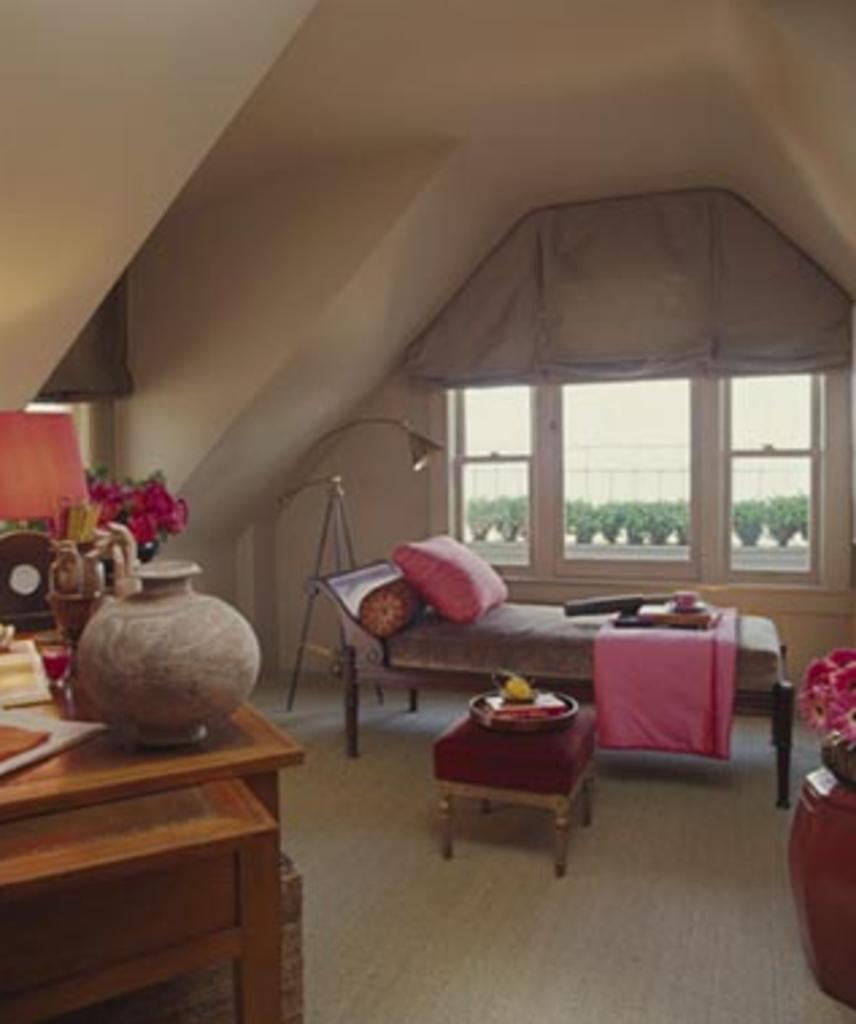How would you summarize this image in a sentence or two? In this image I can see the inner part of the room. I can see few papers, lamp, pot and few objects on the brown color table. I can see the pillow, blanket and few objects on the bed. I can see few objects on the stool. In the background I can see few windows, light and the wall. 